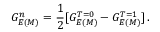Convert formula to latex. <formula><loc_0><loc_0><loc_500><loc_500>G _ { E ( M ) } ^ { n } = \frac { 1 } { 2 } [ G _ { E ( M ) } ^ { T = 0 } - G _ { E ( M ) } ^ { T = 1 } ] \, .</formula> 